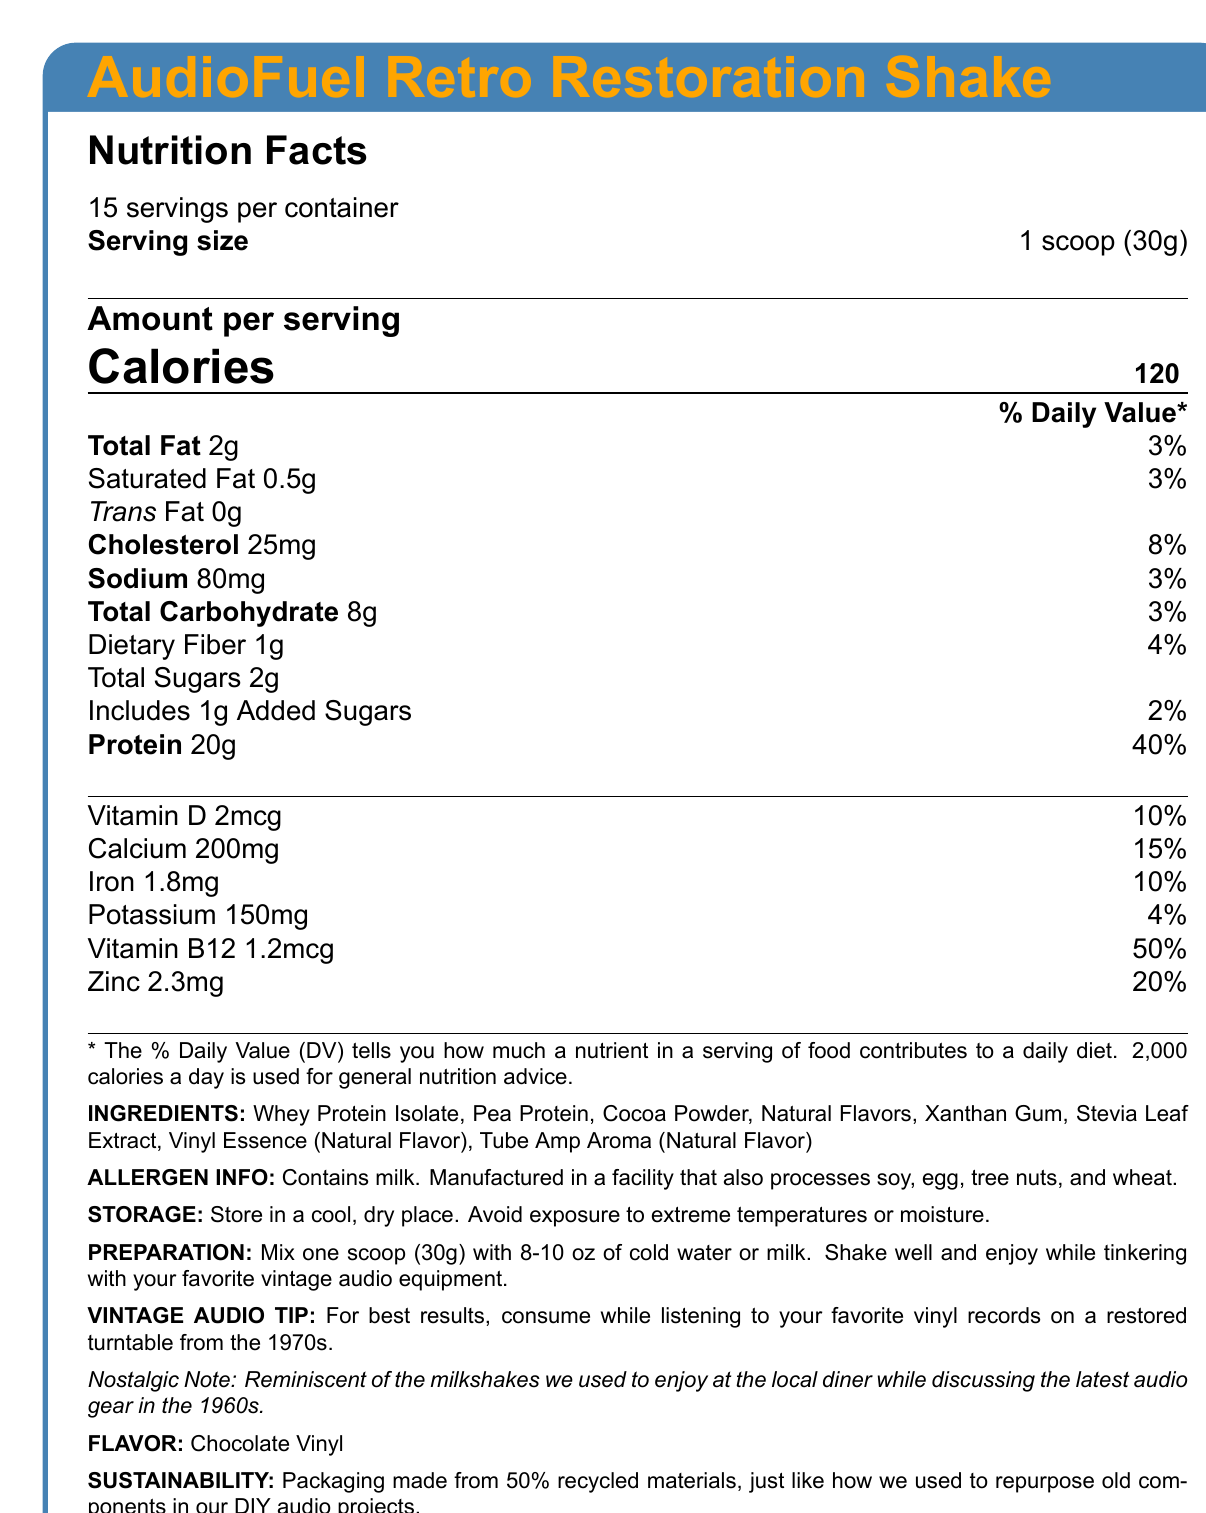What is the serving size of AudioFuel Retro Restoration Shake? The serving size is clearly listed as "1 scoop (30g)" at the beginning of the nutrition facts section.
Answer: 1 scoop (30g) How many calories are in one serving of AudioFuel Retro Restoration Shake? The document states "Calories 120" in the nutrition facts section.
Answer: 120 calories How much protein is in each serving? It's listed in the nutrition facts section under "Protein" with an amount of 20g.
Answer: 20g What is the daily value percentage of Vitamin B12 in each serving? In the nutrition facts section, Vitamin B12 has a daily value percentage of 50%.
Answer: 50% List any allergens mentioned in the document. The allergen info states "Contains milk. Manufactured in a facility that also processes soy, egg, tree nuts, and wheat."
Answer: Milk and possibly soy, egg, tree nuts, and wheat What are the storage instructions for the AudioFuel Retro Restoration Shake? The storage instructions are clearly listed toward the end of the document.
Answer: Store in a cool, dry place. Avoid exposure to extreme temperatures or moisture. How should you prepare the AudioFuel Retro Restoration Shake? The preparation instructions are given in the document detail how to mix the shake.
Answer: Mix one scoop (30g) with 8-10 oz of cold water or milk. Shake well and enjoy while tinkering with your favorite vintage audio equipment. What flavor is the AudioFuel Retro Restoration Shake? The flavor is listed in a dedicated section towards the end of the document as "Chocolate Vinyl."
Answer: Chocolate Vinyl What percentage of calcium does each serving provide based on the daily value? The nutrition facts section lists calcium with a daily value of 15%.
Answer: 15% For best results, when should you consume the AudioFuel Retro Restoration Shake? A. While watching TV B. While reading a book C. While listening to vinyl records D. While exercising The vintage audio tip suggests “For best results, consume while listening to your favorite vinyl records on a restored turntable from the 1970s.”
Answer: C What main ingredient in the shake gives it its primary protein content? A. Cocoa Powder B. Stevia Leaf Extract C. Peanut Butter D. Whey Protein Isolate The primary protein content comes from "Whey Protein Isolate," which is listed as the first ingredient.
Answer: D Is there any trans fat in the AudioFuel Retro Restoration Shake? The nutrition facts list "Trans Fat 0g."
Answer: No Summarize the main idea of the document. The document is mainly focused on delivering all the essential details about the product, including its nutritional benefits, flavor, and special retro-inspired aspects.
Answer: The document provides comprehensive nutritional information and instructions for the AudioFuel Retro Restoration Shake, a retro-inspired protein shake designed for vintage audio enthusiasts. It includes serving size, calorie count, nutrient details, allergen information, preparation and storage instructions, and a nostalgic note. What is Vinyl Essence in the ingredients list? The document lists Vinyl Essence as a Natural Flavor but provides no further details about its specific composition or origin.
Answer: Not enough information How many servings are in one container of AudioFuel Retro Restoration Shake? The document states that there are 15 servings per container.
Answer: 15 What is the nostalgic note about the AudioFuel Retro Restoration Shake? The document includes a nostalgic note at the end describing the shake's reminiscence of past times.
Answer: Reminiscent of the milkshakes we used to enjoy at the local diner while discussing the latest audio gear in the 1960s. 